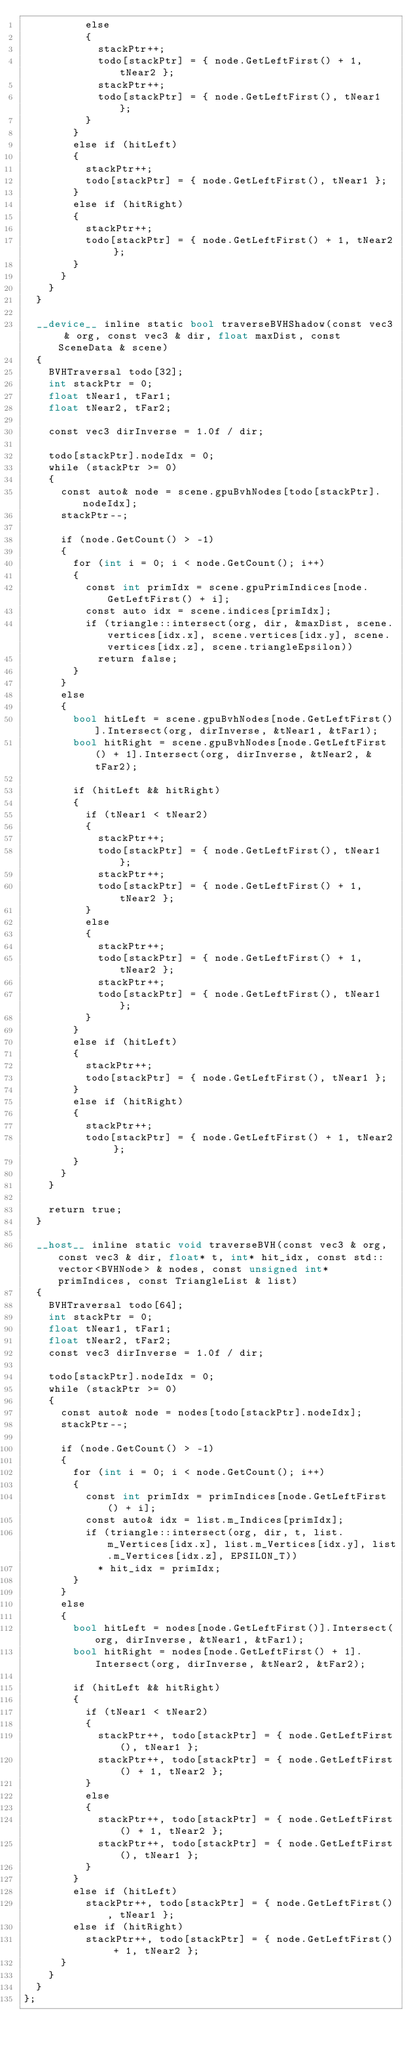<code> <loc_0><loc_0><loc_500><loc_500><_Cuda_>					else
					{
						stackPtr++;
						todo[stackPtr] = { node.GetLeftFirst() + 1, tNear2 };
						stackPtr++;
						todo[stackPtr] = { node.GetLeftFirst(), tNear1 };
					}
				}
				else if (hitLeft)
				{
					stackPtr++;
					todo[stackPtr] = { node.GetLeftFirst(), tNear1 };
				}
				else if (hitRight)
				{
					stackPtr++;
					todo[stackPtr] = { node.GetLeftFirst() + 1, tNear2 };
				}
			}
		}
	}

	__device__ inline static bool traverseBVHShadow(const vec3 & org, const vec3 & dir, float maxDist, const SceneData & scene)
	{
		BVHTraversal todo[32];
		int stackPtr = 0;
		float tNear1, tFar1;
		float tNear2, tFar2;

		const vec3 dirInverse = 1.0f / dir;

		todo[stackPtr].nodeIdx = 0;
		while (stackPtr >= 0)
		{
			const auto& node = scene.gpuBvhNodes[todo[stackPtr].nodeIdx];
			stackPtr--;

			if (node.GetCount() > -1)
			{
				for (int i = 0; i < node.GetCount(); i++)
				{
					const int primIdx = scene.gpuPrimIndices[node.GetLeftFirst() + i];
					const auto idx = scene.indices[primIdx];
					if (triangle::intersect(org, dir, &maxDist, scene.vertices[idx.x], scene.vertices[idx.y], scene.vertices[idx.z], scene.triangleEpsilon))
						return false;
				}
			}
			else
			{
				bool hitLeft = scene.gpuBvhNodes[node.GetLeftFirst()].Intersect(org, dirInverse, &tNear1, &tFar1);
				bool hitRight = scene.gpuBvhNodes[node.GetLeftFirst() + 1].Intersect(org, dirInverse, &tNear2, &tFar2);

				if (hitLeft && hitRight)
				{
					if (tNear1 < tNear2)
					{
						stackPtr++;
						todo[stackPtr] = { node.GetLeftFirst(), tNear1 };
						stackPtr++;
						todo[stackPtr] = { node.GetLeftFirst() + 1, tNear2 };
					}
					else
					{
						stackPtr++;
						todo[stackPtr] = { node.GetLeftFirst() + 1, tNear2 };
						stackPtr++;
						todo[stackPtr] = { node.GetLeftFirst(), tNear1 };
					}
				}
				else if (hitLeft)
				{
					stackPtr++;
					todo[stackPtr] = { node.GetLeftFirst(), tNear1 };
				}
				else if (hitRight)
				{
					stackPtr++;
					todo[stackPtr] = { node.GetLeftFirst() + 1, tNear2 };
				}
			}
		}

		return true;
	}

	__host__ inline static void traverseBVH(const vec3 & org, const vec3 & dir, float* t, int* hit_idx, const std::vector<BVHNode> & nodes, const unsigned int* primIndices, const TriangleList & list)
	{
		BVHTraversal todo[64];
		int stackPtr = 0;
		float tNear1, tFar1;
		float tNear2, tFar2;
		const vec3 dirInverse = 1.0f / dir;

		todo[stackPtr].nodeIdx = 0;
		while (stackPtr >= 0)
		{
			const auto& node = nodes[todo[stackPtr].nodeIdx];
			stackPtr--;

			if (node.GetCount() > -1)
			{
				for (int i = 0; i < node.GetCount(); i++)
				{
					const int primIdx = primIndices[node.GetLeftFirst() + i];
					const auto& idx = list.m_Indices[primIdx];
					if (triangle::intersect(org, dir, t, list.m_Vertices[idx.x], list.m_Vertices[idx.y], list.m_Vertices[idx.z], EPSILON_T))
						* hit_idx = primIdx;
				}
			}
			else
			{
				bool hitLeft = nodes[node.GetLeftFirst()].Intersect(org, dirInverse, &tNear1, &tFar1);
				bool hitRight = nodes[node.GetLeftFirst() + 1].Intersect(org, dirInverse, &tNear2, &tFar2);

				if (hitLeft && hitRight)
				{
					if (tNear1 < tNear2)
					{
						stackPtr++, todo[stackPtr] = { node.GetLeftFirst(), tNear1 };
						stackPtr++, todo[stackPtr] = { node.GetLeftFirst() + 1, tNear2 };
					}
					else
					{
						stackPtr++, todo[stackPtr] = { node.GetLeftFirst() + 1, tNear2 };
						stackPtr++, todo[stackPtr] = { node.GetLeftFirst(), tNear1 };
					}
				}
				else if (hitLeft)
					stackPtr++, todo[stackPtr] = { node.GetLeftFirst(), tNear1 };
				else if (hitRight)
					stackPtr++, todo[stackPtr] = { node.GetLeftFirst() + 1, tNear2 };
			}
		}
	}
};</code> 